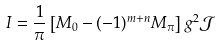Convert formula to latex. <formula><loc_0><loc_0><loc_500><loc_500>I = \frac { 1 } { \pi } \left [ M _ { 0 } - ( - 1 ) ^ { m + n } M _ { \pi } \right ] g ^ { 2 } \mathcal { J }</formula> 